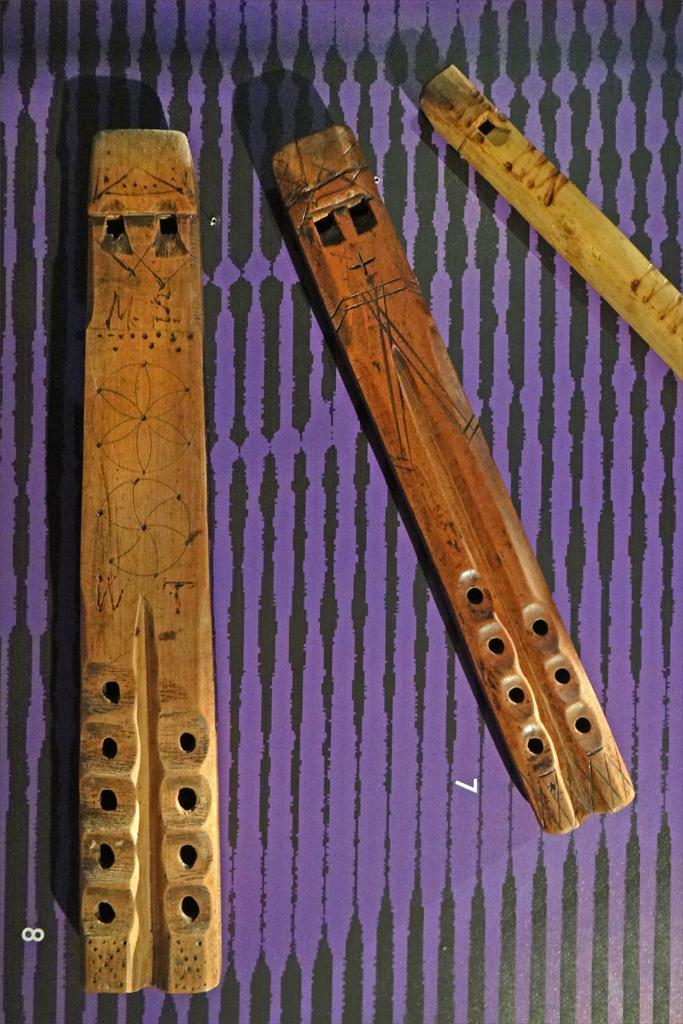What musical instruments are present in the image? There are three flutes in the image. Where are the flutes placed? The flutes are placed on an object. Can you describe the color of the object? The object is violet in color. Are there any other notable features on the object? Yes, there are black lines on the object. What type of fowl is sitting on the violet object in the image? There is no fowl present in the image; it only features three flutes and a violet object with black lines. 